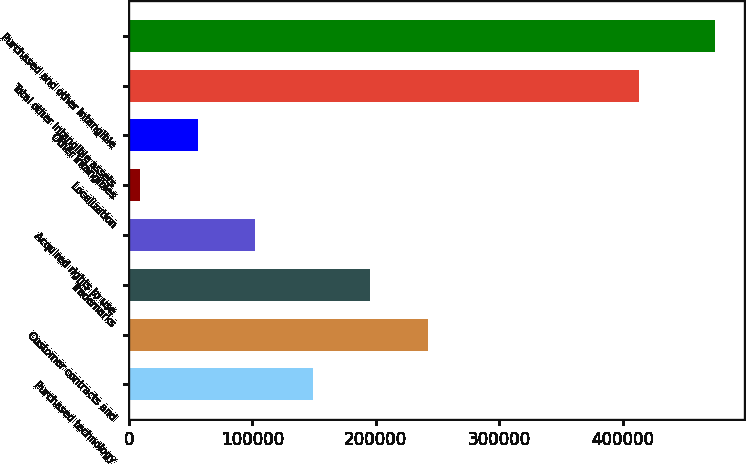Convert chart. <chart><loc_0><loc_0><loc_500><loc_500><bar_chart><fcel>Purchased technology<fcel>Customer contracts and<fcel>Trademarks<fcel>Acquired rights to use<fcel>Localization<fcel>Other intangibles<fcel>Total other intangible assets<fcel>Purchased and other intangible<nl><fcel>148985<fcel>242072<fcel>195529<fcel>102442<fcel>9355<fcel>55898.4<fcel>412802<fcel>474789<nl></chart> 